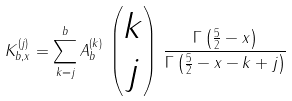<formula> <loc_0><loc_0><loc_500><loc_500>K _ { b , x } ^ { ( j ) } = \sum _ { k = j } ^ { b } A _ { b } ^ { ( k ) } \, \begin{pmatrix} k \\ j \end{pmatrix} \, \frac { \Gamma \left ( \frac { 5 } { 2 } - x \right ) } { \Gamma \left ( \frac { 5 } { 2 } - x - k + j \right ) }</formula> 